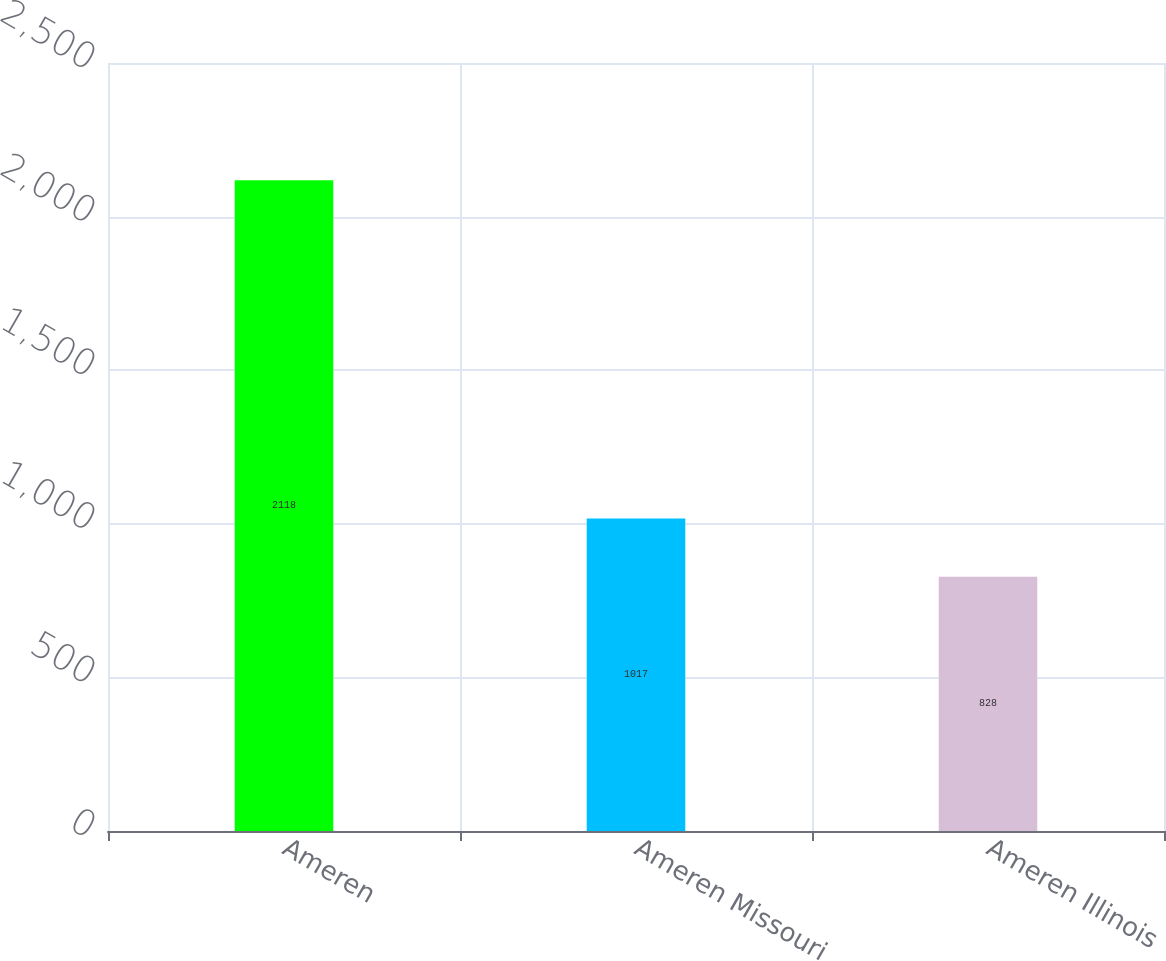Convert chart to OTSL. <chart><loc_0><loc_0><loc_500><loc_500><bar_chart><fcel>Ameren<fcel>Ameren Missouri<fcel>Ameren Illinois<nl><fcel>2118<fcel>1017<fcel>828<nl></chart> 